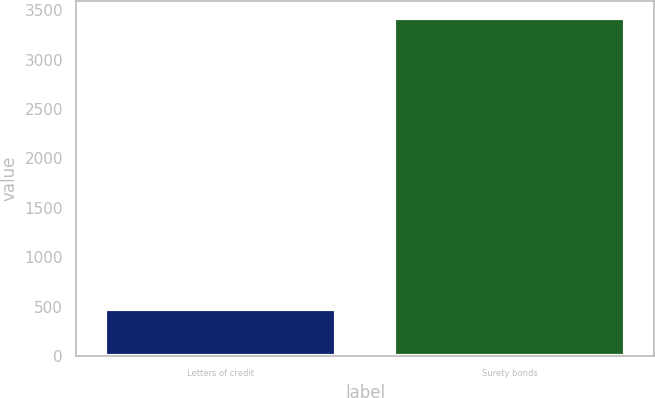<chart> <loc_0><loc_0><loc_500><loc_500><bar_chart><fcel>Letters of credit<fcel>Surety bonds<nl><fcel>474.2<fcel>3418.5<nl></chart> 